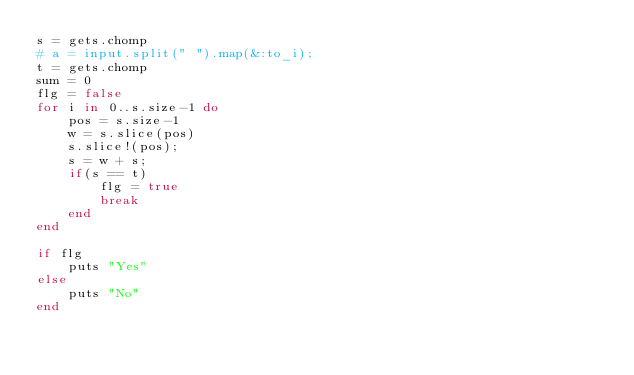Convert code to text. <code><loc_0><loc_0><loc_500><loc_500><_Ruby_>s = gets.chomp
# a = input.split(" ").map(&:to_i);
t = gets.chomp
sum = 0
flg = false
for i in 0..s.size-1 do
    pos = s.size-1
    w = s.slice(pos)
    s.slice!(pos);
    s = w + s;
    if(s == t) 
        flg = true
        break
    end
end

if flg
    puts "Yes"
else
    puts "No"
end</code> 